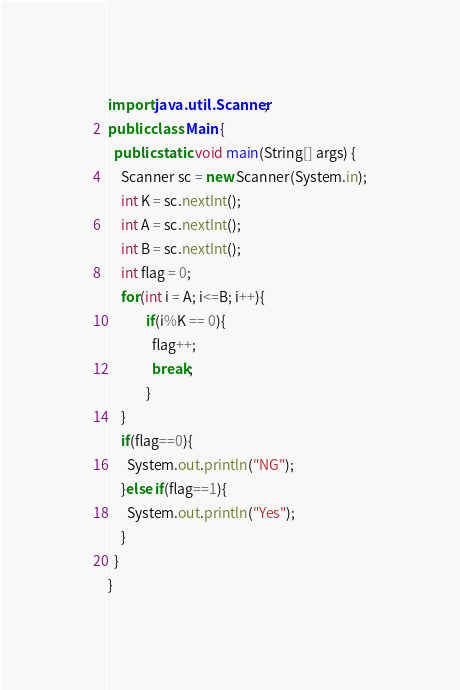<code> <loc_0><loc_0><loc_500><loc_500><_Java_>import java.util.Scanner;
public class Main {
  public static void main(String[] args) {
    Scanner sc = new Scanner(System.in);
    int K = sc.nextInt();
    int A = sc.nextInt();
    int B = sc.nextInt();
    int flag = 0;
    for(int i = A; i<=B; i++){
            if(i%K == 0){
              flag++;
              break;
            }
    }
    if(flag==0){
      System.out.println("NG");
    }else if(flag==1){
      System.out.println("Yes");
    }
  }
}</code> 